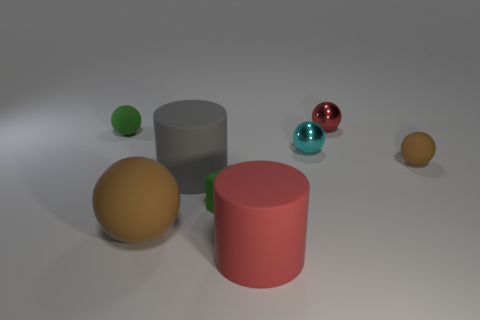Add 1 brown cubes. How many objects exist? 9 Subtract all brown balls. How many balls are left? 3 Subtract all big spheres. How many spheres are left? 4 Subtract all gray cylinders. How many red spheres are left? 1 Subtract all large green metallic things. Subtract all big matte cylinders. How many objects are left? 6 Add 4 big brown things. How many big brown things are left? 5 Add 8 small red things. How many small red things exist? 9 Subtract 1 red balls. How many objects are left? 7 Subtract all cubes. How many objects are left? 7 Subtract 3 balls. How many balls are left? 2 